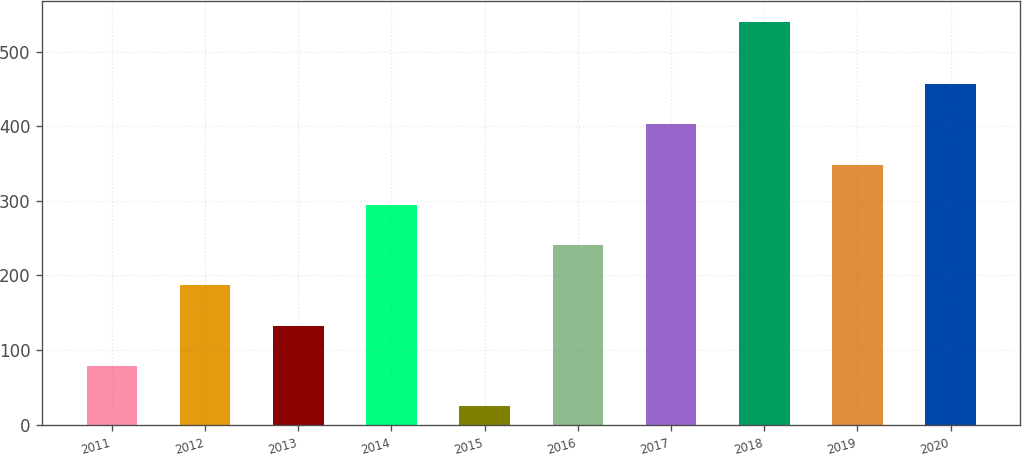<chart> <loc_0><loc_0><loc_500><loc_500><bar_chart><fcel>2011<fcel>2012<fcel>2013<fcel>2014<fcel>2015<fcel>2016<fcel>2017<fcel>2018<fcel>2019<fcel>2020<nl><fcel>78.9<fcel>186.7<fcel>132.8<fcel>294.5<fcel>25<fcel>240.6<fcel>402.3<fcel>540<fcel>348.4<fcel>456.2<nl></chart> 